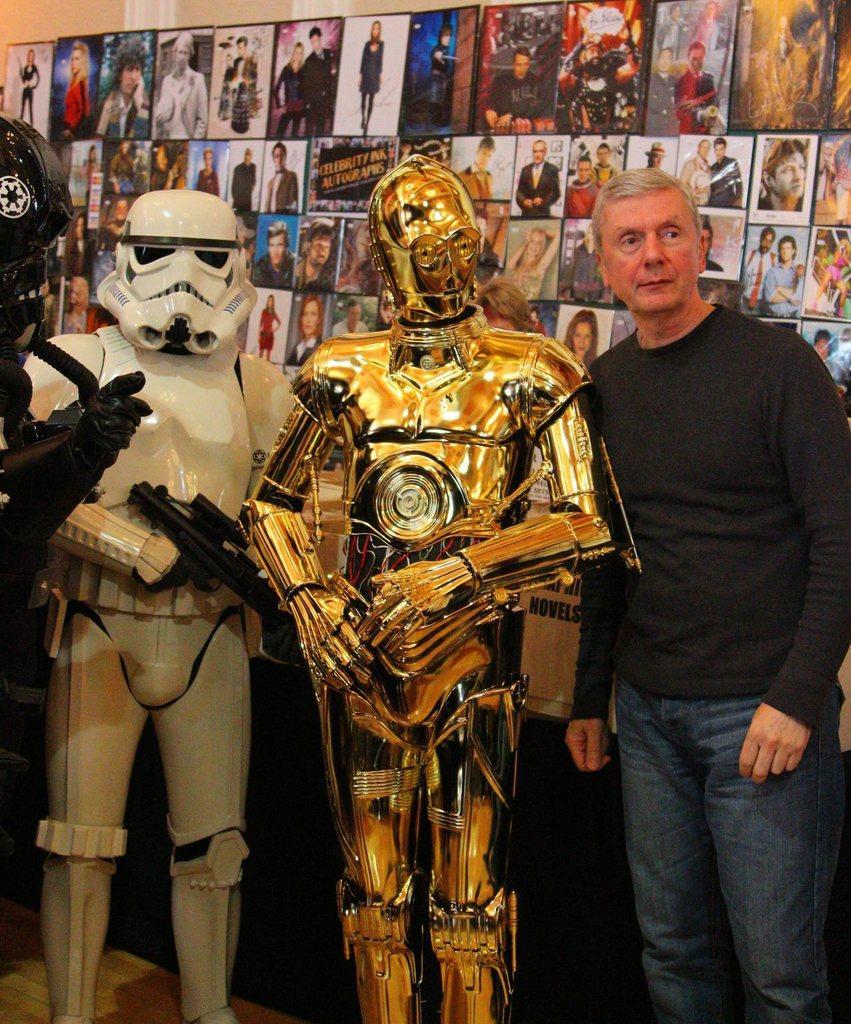Could you give a brief overview of what you see in this image? In this image on the left there are three toy robots. On the right there is a man, he wears a t shirt, trouser, he is standing. In the background there are many photo frames, wall. 